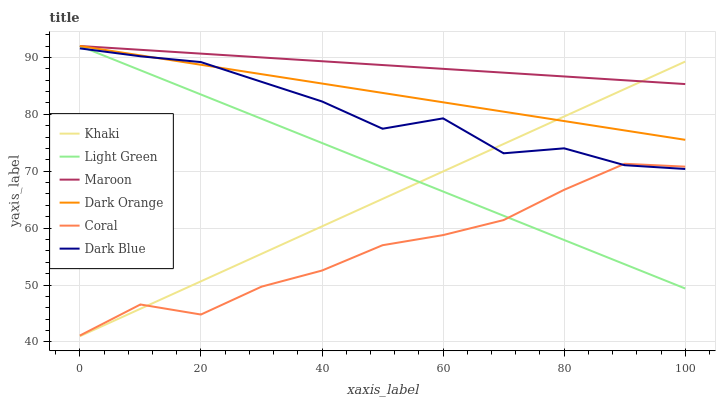Does Coral have the minimum area under the curve?
Answer yes or no. Yes. Does Maroon have the maximum area under the curve?
Answer yes or no. Yes. Does Khaki have the minimum area under the curve?
Answer yes or no. No. Does Khaki have the maximum area under the curve?
Answer yes or no. No. Is Light Green the smoothest?
Answer yes or no. Yes. Is Dark Blue the roughest?
Answer yes or no. Yes. Is Khaki the smoothest?
Answer yes or no. No. Is Khaki the roughest?
Answer yes or no. No. Does Khaki have the lowest value?
Answer yes or no. Yes. Does Coral have the lowest value?
Answer yes or no. No. Does Light Green have the highest value?
Answer yes or no. Yes. Does Khaki have the highest value?
Answer yes or no. No. Is Coral less than Dark Orange?
Answer yes or no. Yes. Is Maroon greater than Coral?
Answer yes or no. Yes. Does Coral intersect Light Green?
Answer yes or no. Yes. Is Coral less than Light Green?
Answer yes or no. No. Is Coral greater than Light Green?
Answer yes or no. No. Does Coral intersect Dark Orange?
Answer yes or no. No. 